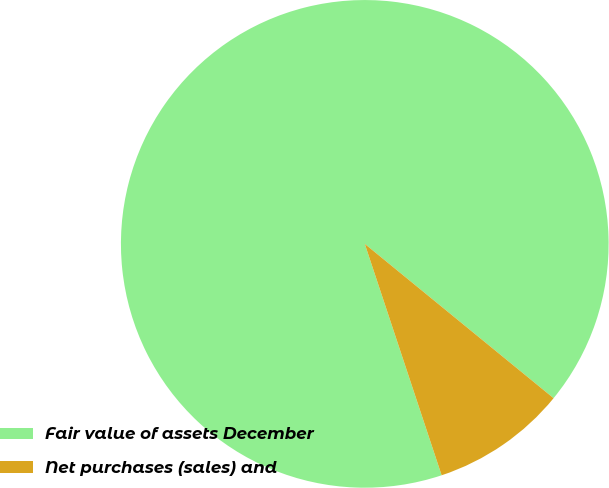<chart> <loc_0><loc_0><loc_500><loc_500><pie_chart><fcel>Fair value of assets December<fcel>Net purchases (sales) and<nl><fcel>91.01%<fcel>8.99%<nl></chart> 